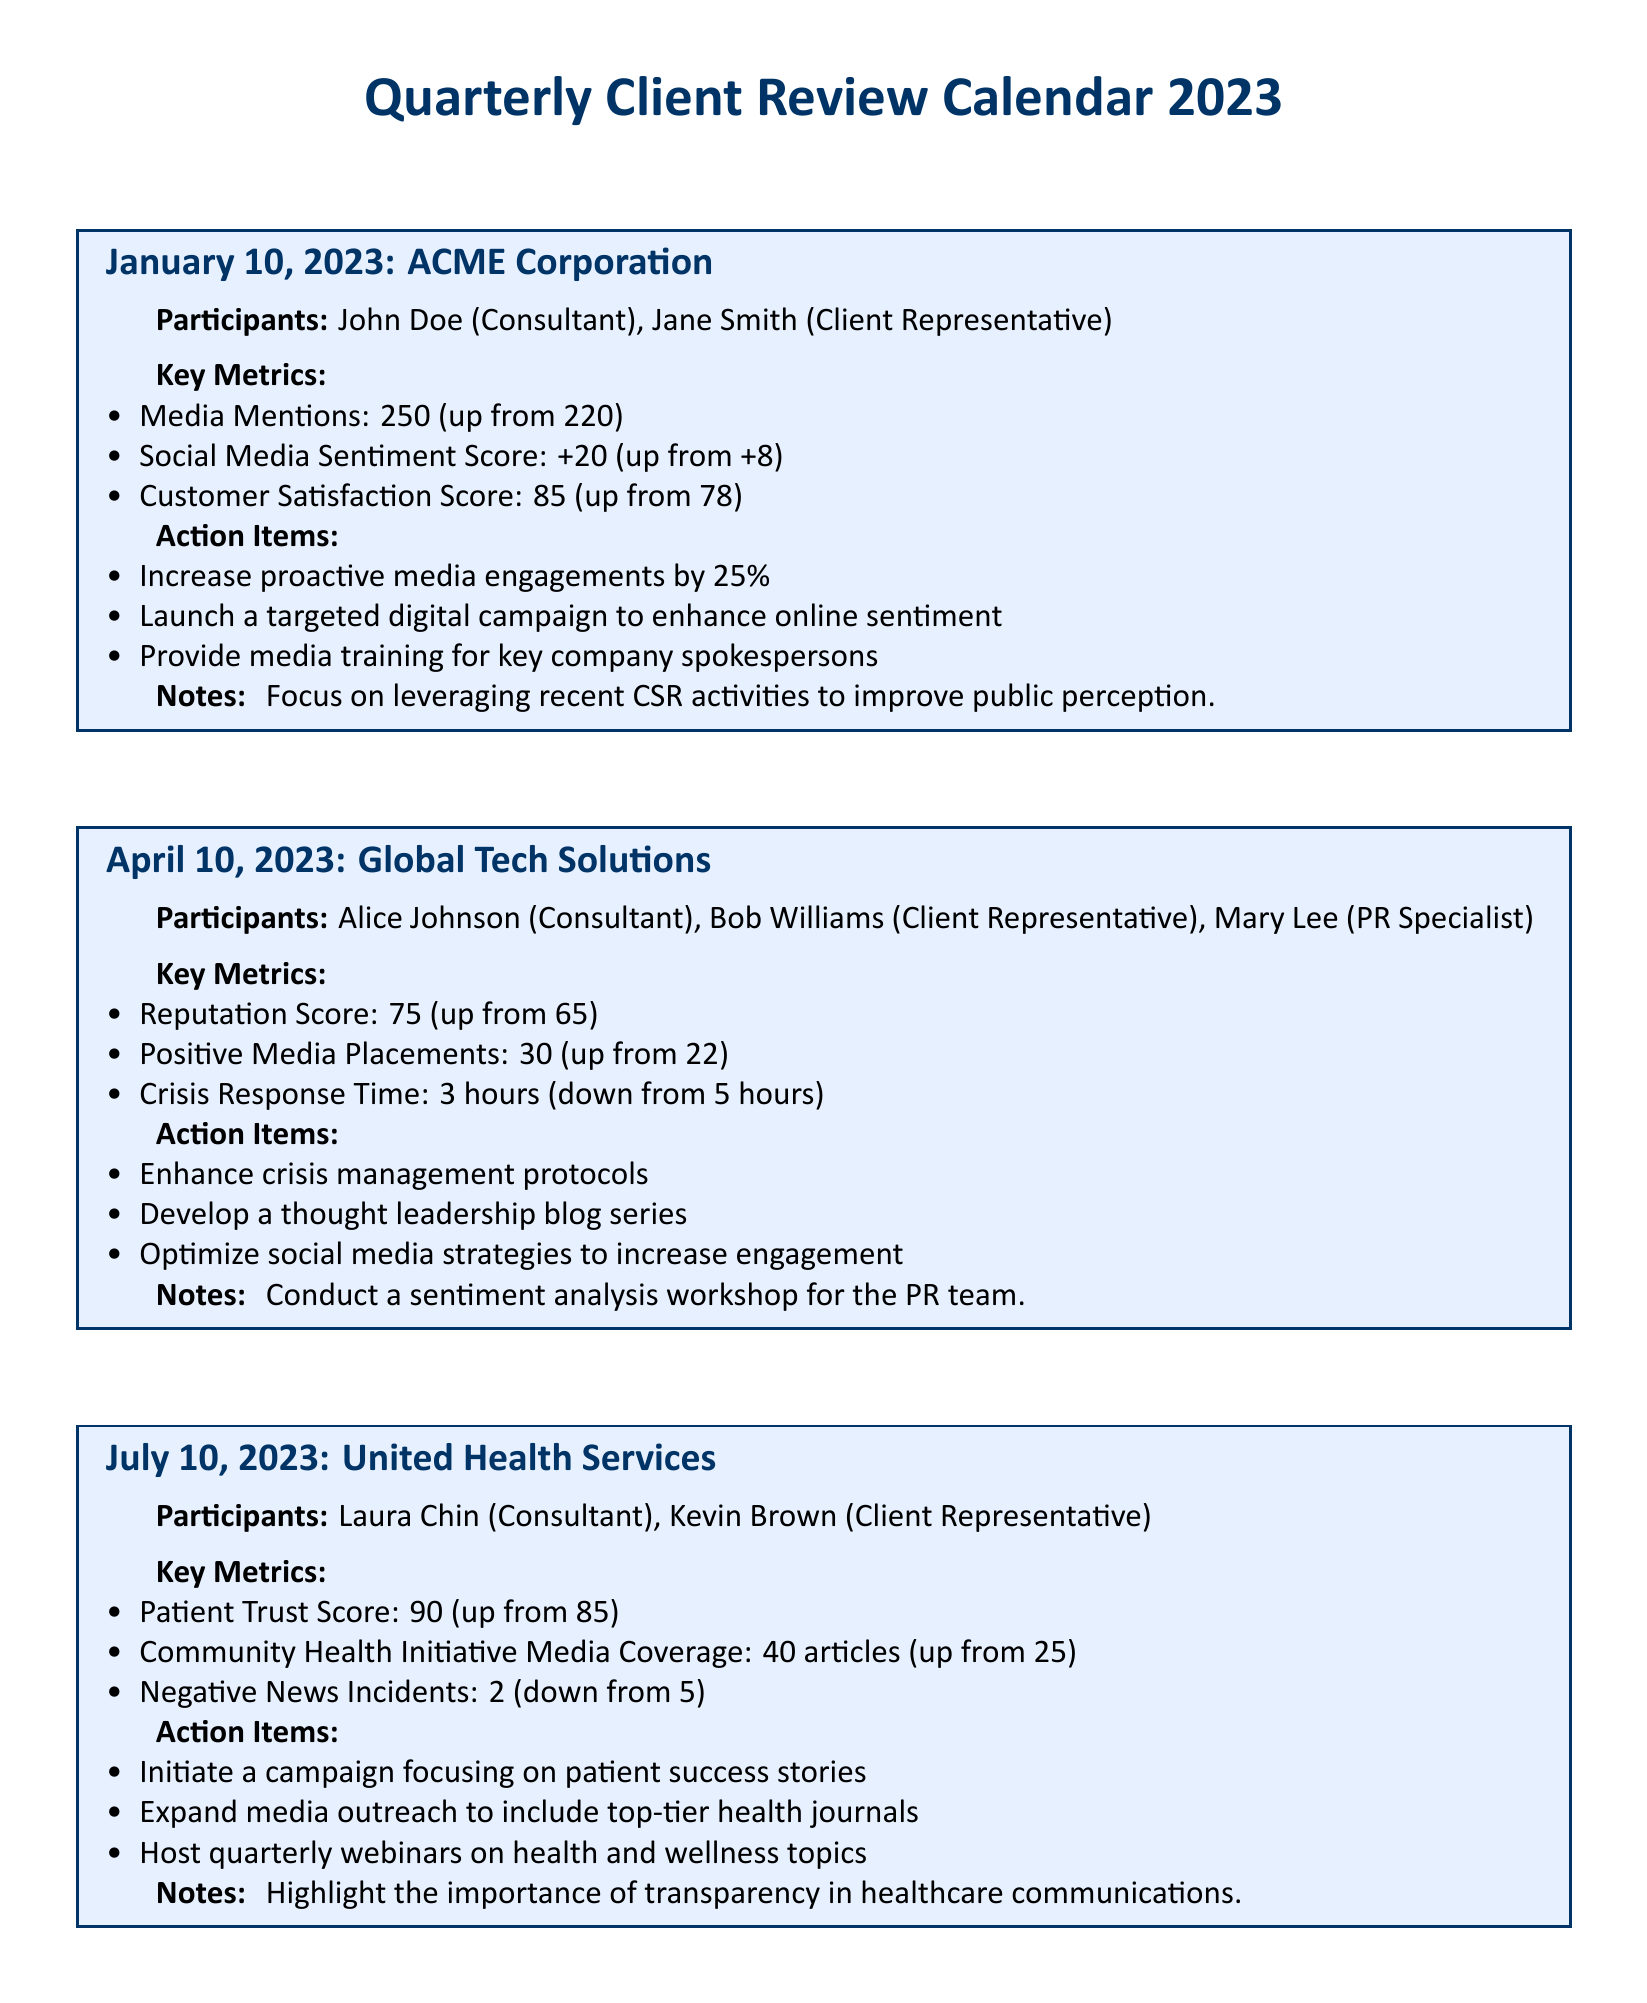What is the date of the first review session? The date of the first review session is explicitly mentioned in the document as January 10, 2023.
Answer: January 10, 2023 Who represented ACME Corporation in the review session? The client representative for ACME Corporation during the review session is Jane Smith.
Answer: Jane Smith What was the media mentions count for Global Tech Solutions? The media mentions count for Global Tech Solutions is provided in the document as 30 positive media placements, noting an improvement from the previous quarter.
Answer: 30 What is the action item related to media training in the January session? The specific action item regarding media training in the January session is to provide media training for key company spokespersons.
Answer: Provide media training for key company spokespersons Which client had a Patient Trust Score of 90? The document explicitly indicates that United Health Services had a Patient Trust Score of 90 in their review session.
Answer: United Health Services What notable improvement was mentioned for the crisis response time in April? The document states that the crisis response time improved from 5 hours to 3 hours in the April session.
Answer: 3 hours How many articles covered the Community Health Initiative in July? The number of articles that covered the Community Health Initiative in July is provided as 40.
Answer: 40 What was the primary focus identified in the notes for the July session? The primary focus identified in the notes for the July session is the importance of transparency in healthcare communications.
Answer: Importance of transparency in healthcare communications 